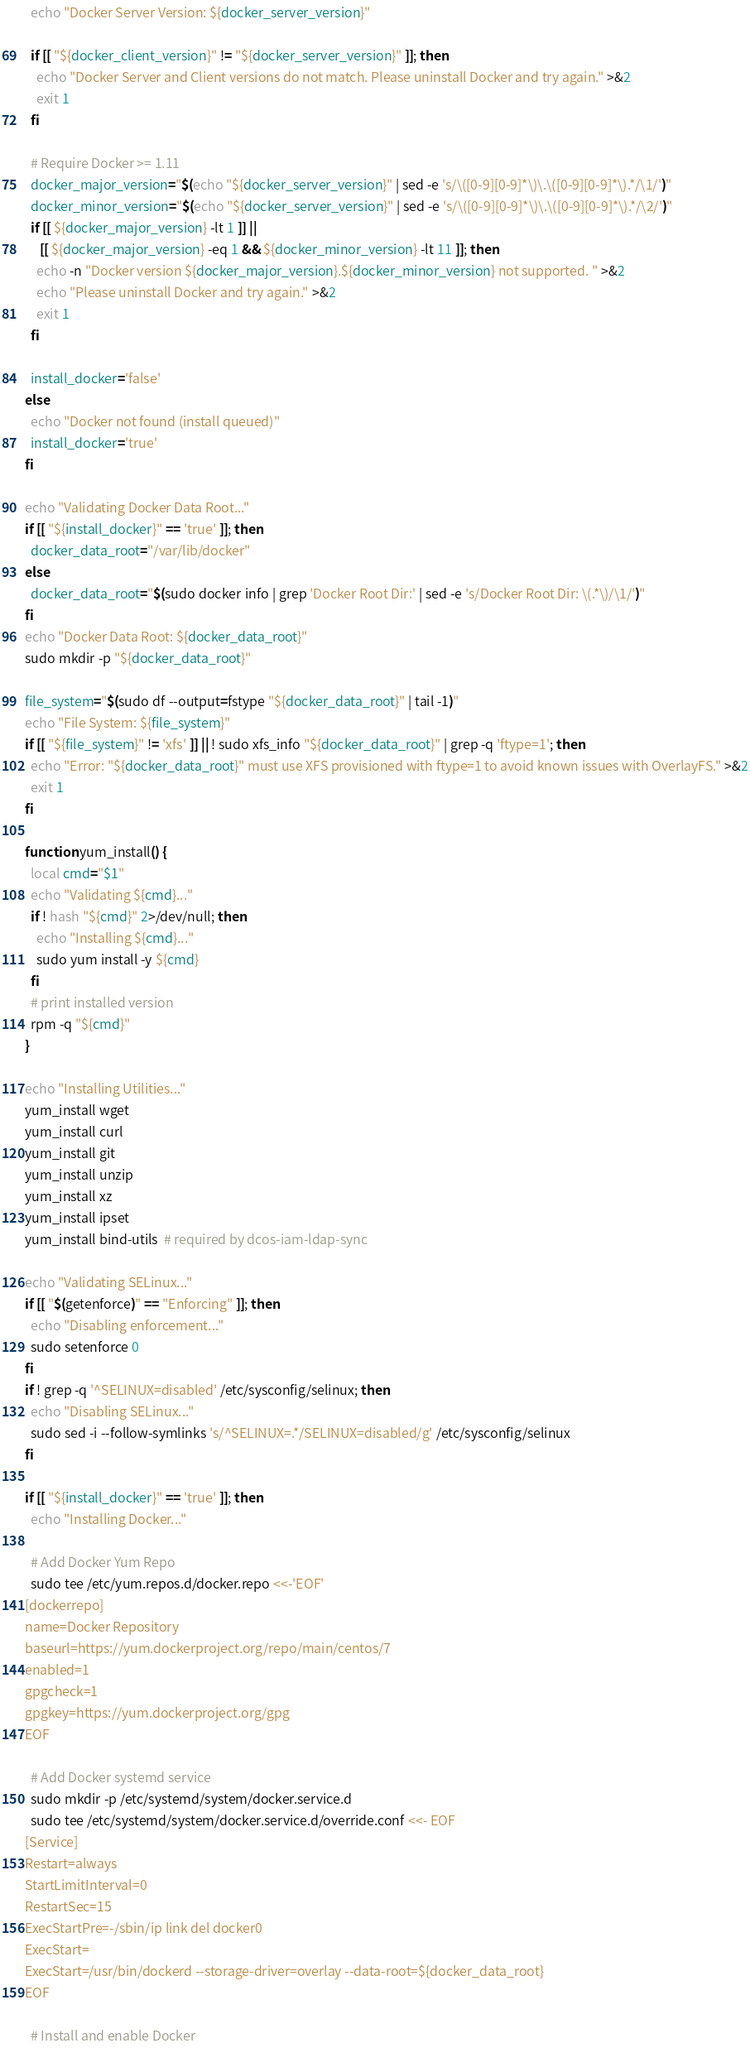<code> <loc_0><loc_0><loc_500><loc_500><_Bash_>  echo "Docker Server Version: ${docker_server_version}"

  if [[ "${docker_client_version}" != "${docker_server_version}" ]]; then
    echo "Docker Server and Client versions do not match. Please uninstall Docker and try again." >&2
    exit 1
  fi

  # Require Docker >= 1.11
  docker_major_version="$(echo "${docker_server_version}" | sed -e 's/\([0-9][0-9]*\)\.\([0-9][0-9]*\).*/\1/')"
  docker_minor_version="$(echo "${docker_server_version}" | sed -e 's/\([0-9][0-9]*\)\.\([0-9][0-9]*\).*/\2/')"
  if [[ ${docker_major_version} -lt 1 ]] ||
     [[ ${docker_major_version} -eq 1 && ${docker_minor_version} -lt 11 ]]; then
    echo -n "Docker version ${docker_major_version}.${docker_minor_version} not supported. " >&2
    echo "Please uninstall Docker and try again." >&2
    exit 1
  fi

  install_docker='false'
else
  echo "Docker not found (install queued)"
  install_docker='true'
fi

echo "Validating Docker Data Root..."
if [[ "${install_docker}" == 'true' ]]; then
  docker_data_root="/var/lib/docker"
else
  docker_data_root="$(sudo docker info | grep 'Docker Root Dir:' | sed -e 's/Docker Root Dir: \(.*\)/\1/')"
fi
echo "Docker Data Root: ${docker_data_root}"
sudo mkdir -p "${docker_data_root}"

file_system="$(sudo df --output=fstype "${docker_data_root}" | tail -1)"
echo "File System: ${file_system}"
if [[ "${file_system}" != 'xfs' ]] || ! sudo xfs_info "${docker_data_root}" | grep -q 'ftype=1'; then
  echo "Error: "${docker_data_root}" must use XFS provisioned with ftype=1 to avoid known issues with OverlayFS." >&2
  exit 1
fi

function yum_install() {
  local cmd="$1"
  echo "Validating ${cmd}..."
  if ! hash "${cmd}" 2>/dev/null; then
    echo "Installing ${cmd}..."
    sudo yum install -y ${cmd}
  fi
  # print installed version
  rpm -q "${cmd}"
}

echo "Installing Utilities..."
yum_install wget
yum_install curl
yum_install git
yum_install unzip
yum_install xz
yum_install ipset
yum_install bind-utils  # required by dcos-iam-ldap-sync

echo "Validating SELinux..."
if [[ "$(getenforce)" == "Enforcing" ]]; then
  echo "Disabling enforcement..."
  sudo setenforce 0
fi
if ! grep -q '^SELINUX=disabled' /etc/sysconfig/selinux; then
  echo "Disabling SELinux..."
  sudo sed -i --follow-symlinks 's/^SELINUX=.*/SELINUX=disabled/g' /etc/sysconfig/selinux
fi

if [[ "${install_docker}" == 'true' ]]; then
  echo "Installing Docker..."

  # Add Docker Yum Repo
  sudo tee /etc/yum.repos.d/docker.repo <<-'EOF'
[dockerrepo]
name=Docker Repository
baseurl=https://yum.dockerproject.org/repo/main/centos/7
enabled=1
gpgcheck=1
gpgkey=https://yum.dockerproject.org/gpg
EOF

  # Add Docker systemd service
  sudo mkdir -p /etc/systemd/system/docker.service.d
  sudo tee /etc/systemd/system/docker.service.d/override.conf <<- EOF
[Service]
Restart=always
StartLimitInterval=0
RestartSec=15
ExecStartPre=-/sbin/ip link del docker0
ExecStart=
ExecStart=/usr/bin/dockerd --storage-driver=overlay --data-root=${docker_data_root}
EOF

  # Install and enable Docker</code> 